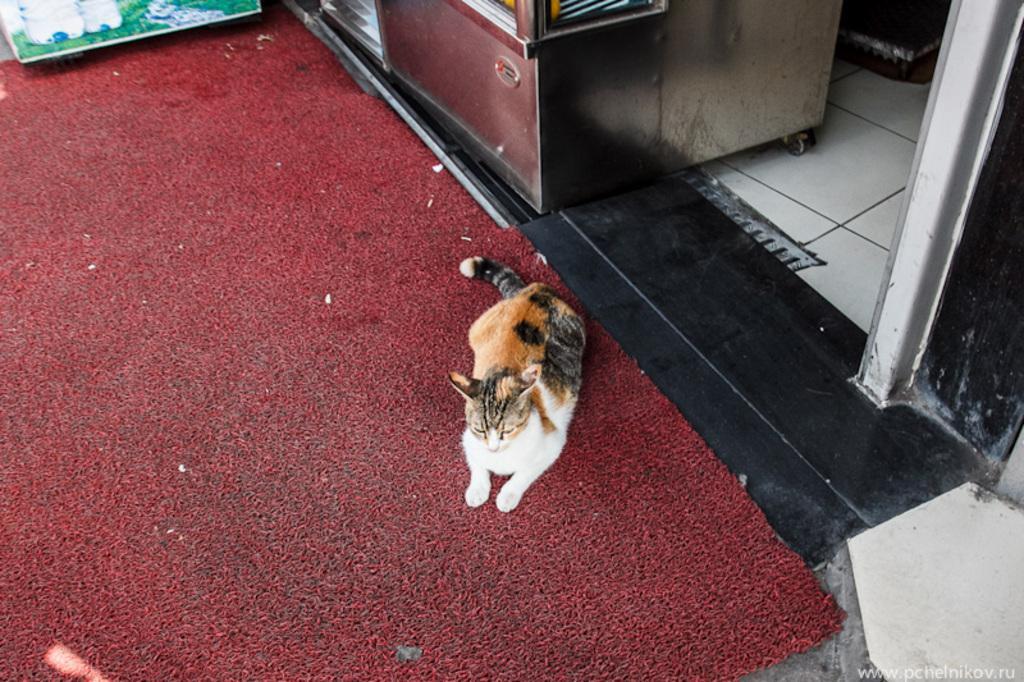In one or two sentences, can you explain what this image depicts? There is a cat sitting on mat and we can see mat and maroon color object on floor. 